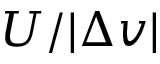<formula> <loc_0><loc_0><loc_500><loc_500>U / | \Delta v |</formula> 